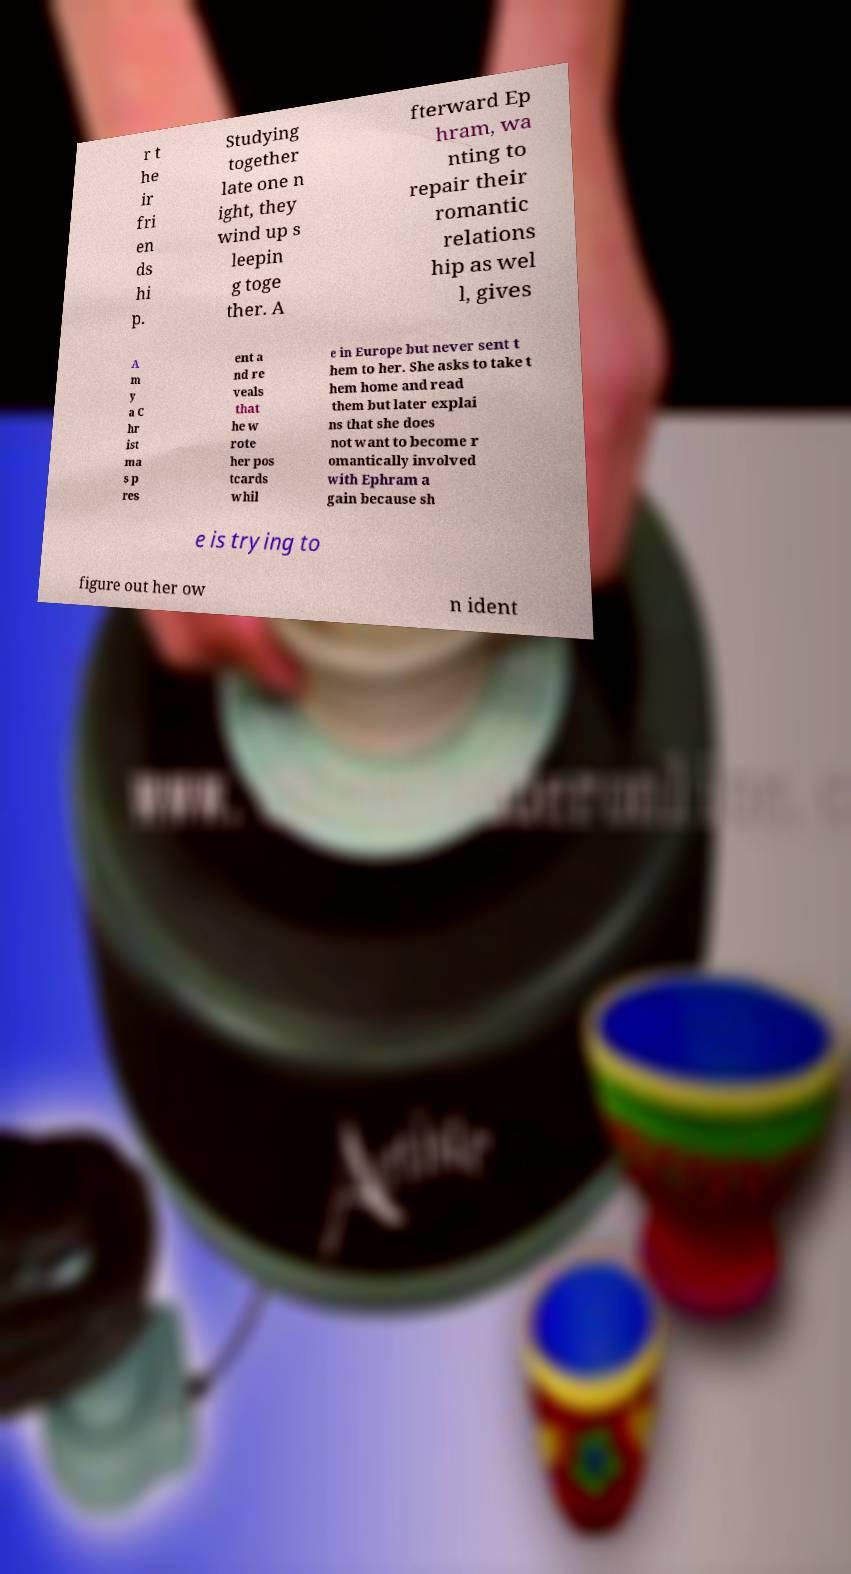What messages or text are displayed in this image? I need them in a readable, typed format. r t he ir fri en ds hi p. Studying together late one n ight, they wind up s leepin g toge ther. A fterward Ep hram, wa nting to repair their romantic relations hip as wel l, gives A m y a C hr ist ma s p res ent a nd re veals that he w rote her pos tcards whil e in Europe but never sent t hem to her. She asks to take t hem home and read them but later explai ns that she does not want to become r omantically involved with Ephram a gain because sh e is trying to figure out her ow n ident 